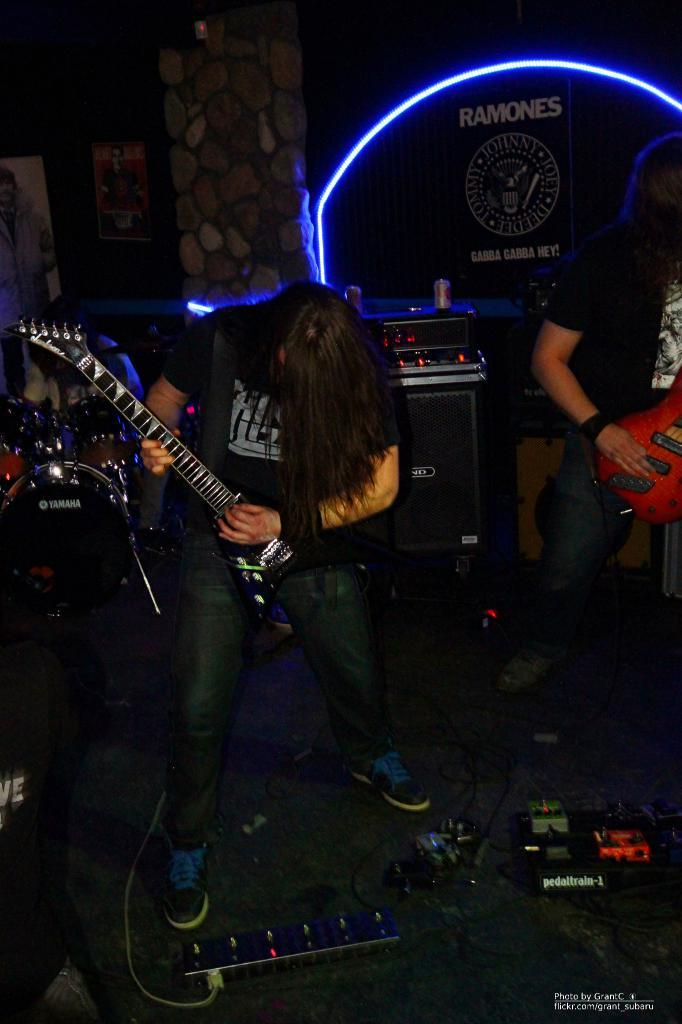How many people are in the image? There are two men in the image. What are the men doing in the image? The men are playing guitars. Where are the men located in the image? The men are on a stage. What type of vase can be seen on the stage in the image? There is no vase present on the stage in the image. What type of poison might the men be using to play their guitars in the image? There is no indication in the image that the men are using any type of poison to play their guitars. 